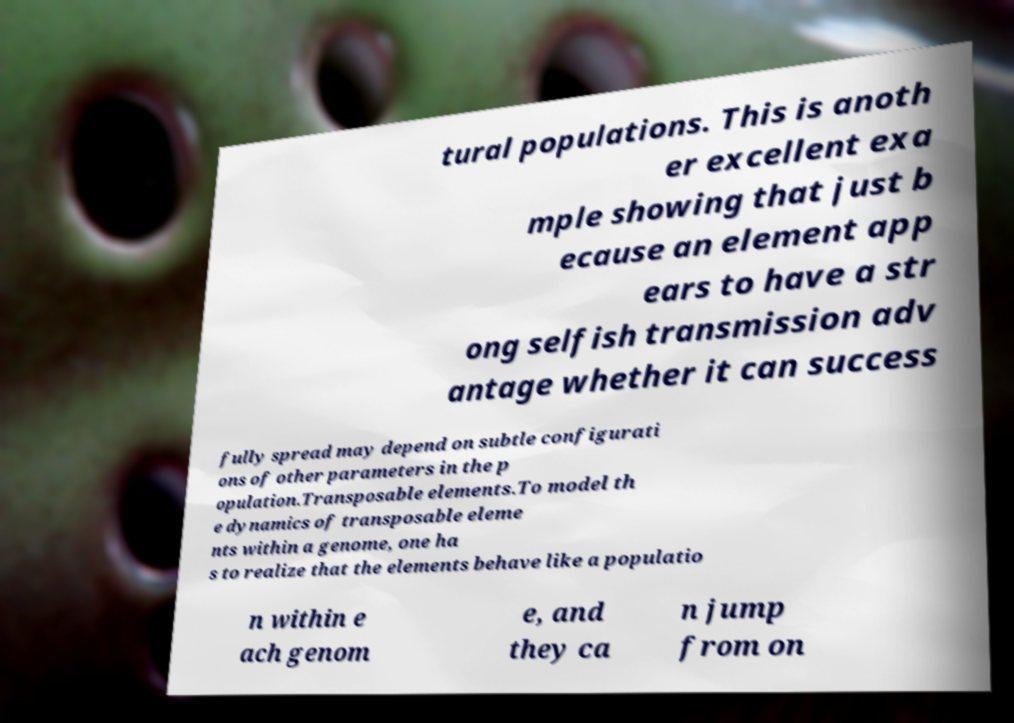Please read and relay the text visible in this image. What does it say? tural populations. This is anoth er excellent exa mple showing that just b ecause an element app ears to have a str ong selfish transmission adv antage whether it can success fully spread may depend on subtle configurati ons of other parameters in the p opulation.Transposable elements.To model th e dynamics of transposable eleme nts within a genome, one ha s to realize that the elements behave like a populatio n within e ach genom e, and they ca n jump from on 